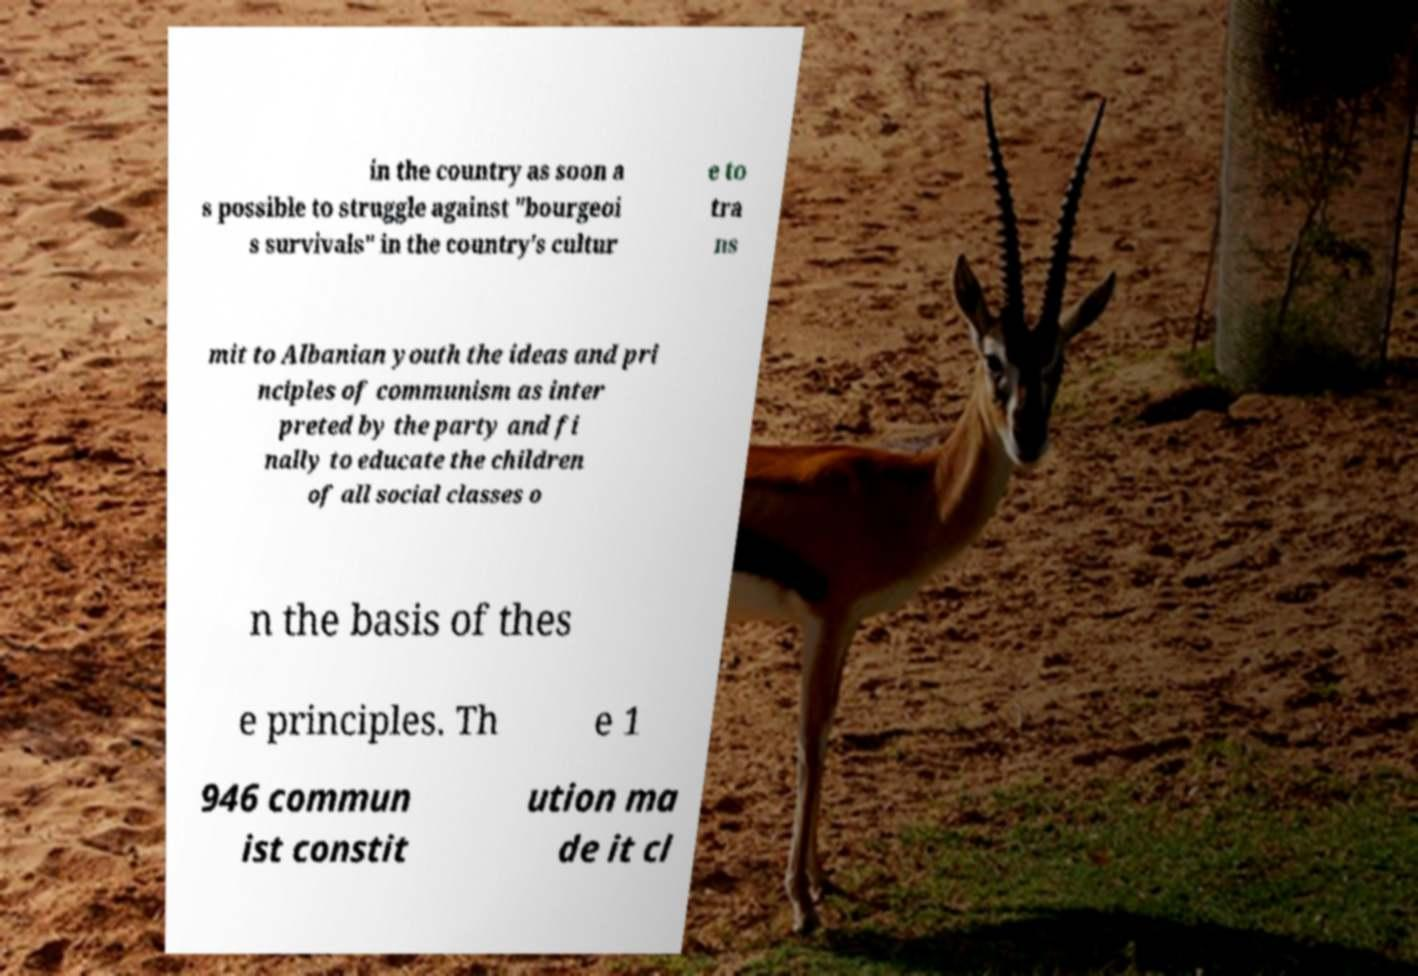There's text embedded in this image that I need extracted. Can you transcribe it verbatim? in the country as soon a s possible to struggle against "bourgeoi s survivals" in the country's cultur e to tra ns mit to Albanian youth the ideas and pri nciples of communism as inter preted by the party and fi nally to educate the children of all social classes o n the basis of thes e principles. Th e 1 946 commun ist constit ution ma de it cl 